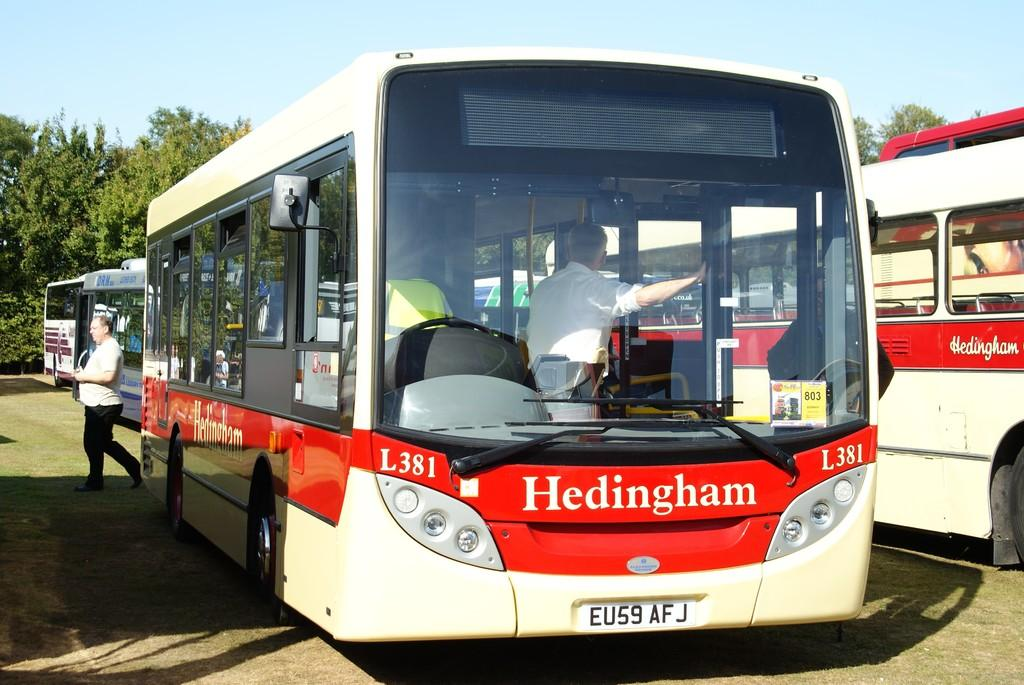What type of vehicles are in the foreground of the image? There are buses in the foreground of the image. Where are the buses located? The buses are on the road. What is the man in the image doing? There is a man walking in the image. What can be seen in the background of the image? There are trees, additional buses, and the sky visible in the background of the image. Can you hear the cushion in the image? There is no cushion present in the image, so it cannot be heard. 